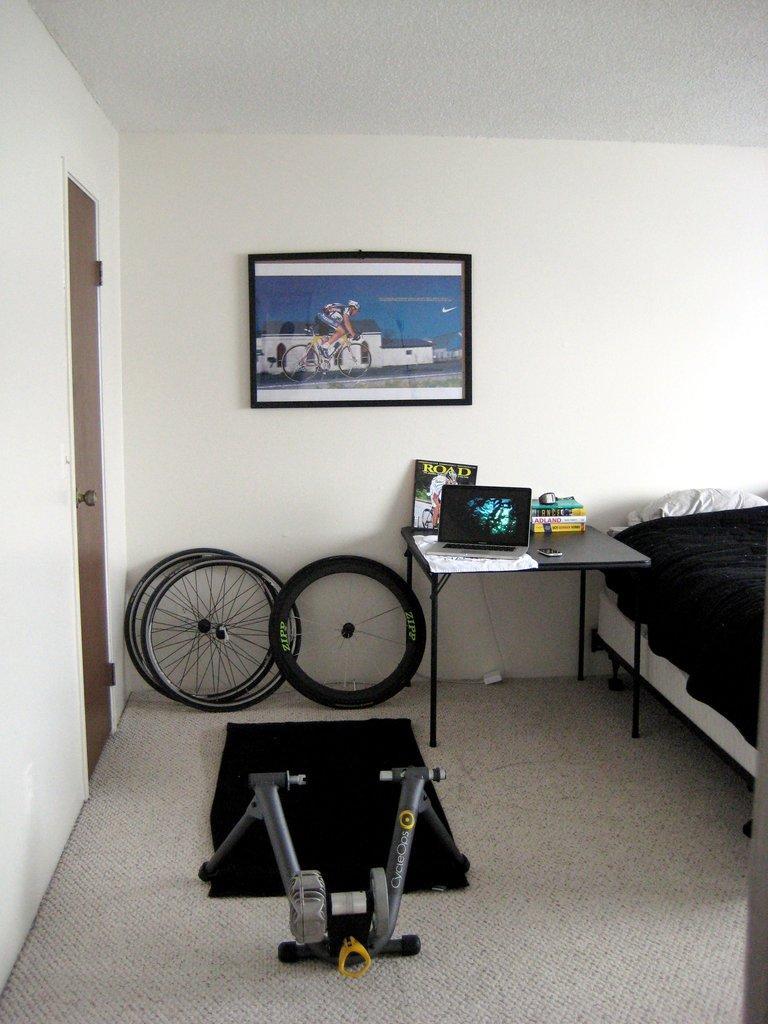Please provide a concise description of this image. A picture of a room. A painting is on wall. In-front of this wall there are wheels. On floor there is a gym equipment. On the right side of the image we can able to see bed with pillow. Beside this bed there is a table, on this table there is a laptop, book, mobile and paper. Beside this wheel's there is a door with handle. 